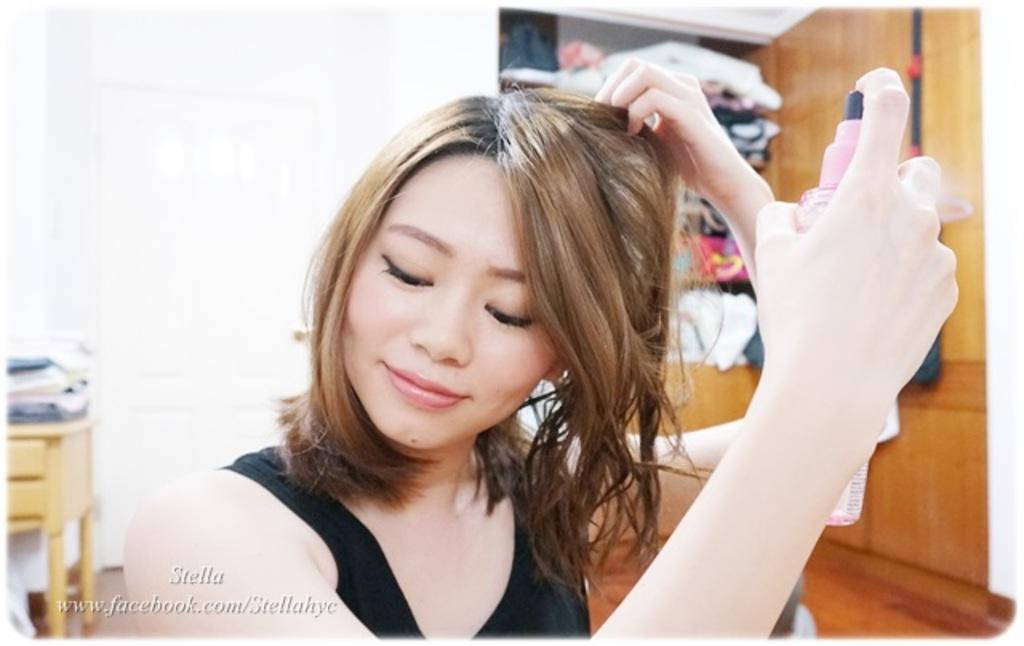What is the main subject of the image? There is a woman in the image. What is the woman doing with her left hand? The woman is holding her hair with her left hand. What is the woman holding in her right hand? The woman is holding a bottle with her right hand. What is the woman's facial expression in the image? The woman is smiling. How does the woman stretch her arms in the image? The image does not show the woman stretching her arms; she is holding her hair and a bottle. 